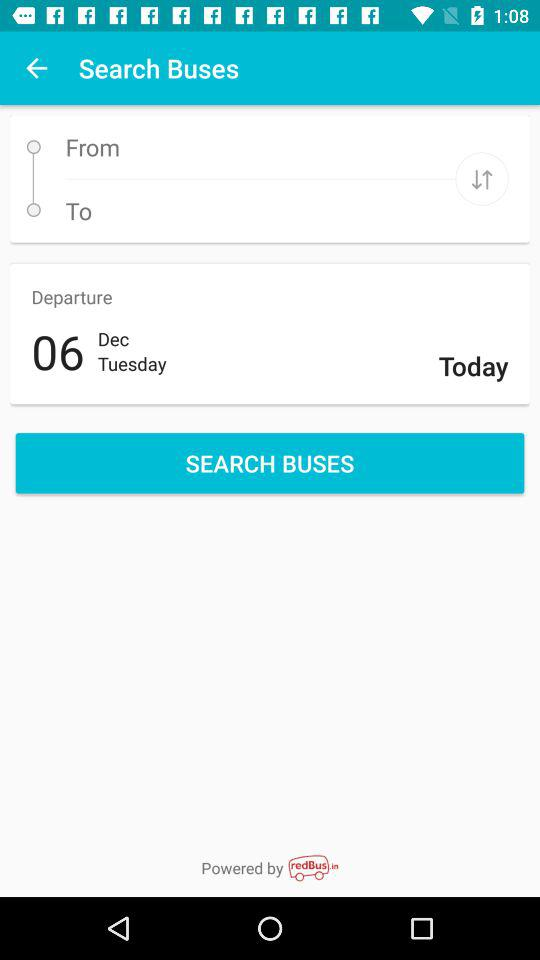What is the date of departure? The date of departure is Tuesday, December 6. 